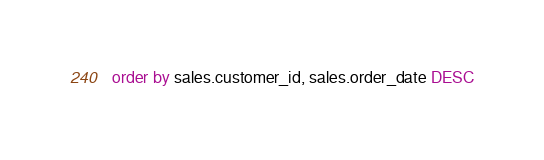<code> <loc_0><loc_0><loc_500><loc_500><_SQL_>order by sales.customer_id, sales.order_date DESC


</code> 